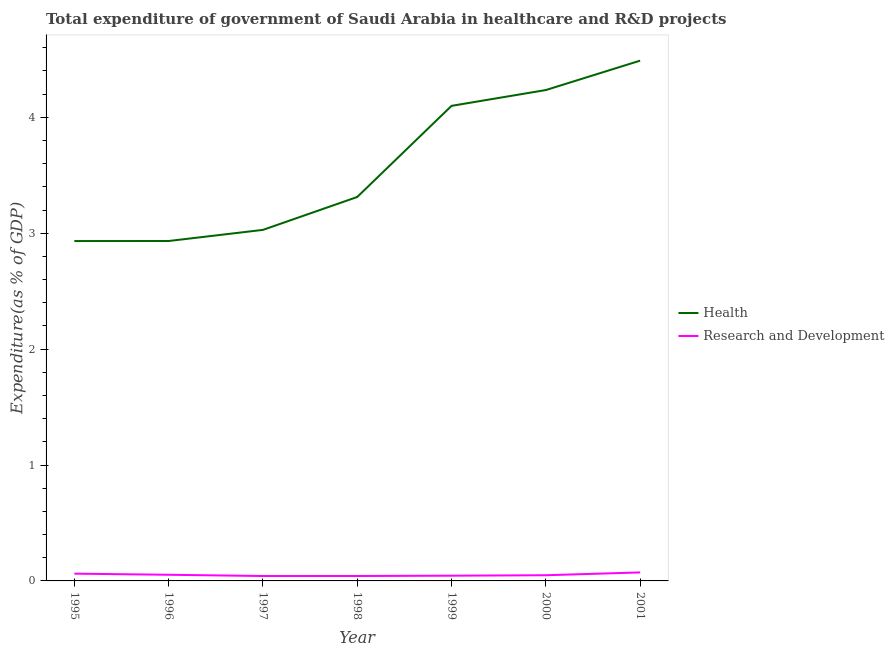Does the line corresponding to expenditure in r&d intersect with the line corresponding to expenditure in healthcare?
Offer a terse response. No. What is the expenditure in r&d in 2001?
Your response must be concise. 0.07. Across all years, what is the maximum expenditure in r&d?
Offer a very short reply. 0.07. Across all years, what is the minimum expenditure in r&d?
Provide a succinct answer. 0.04. In which year was the expenditure in r&d maximum?
Your response must be concise. 2001. What is the total expenditure in healthcare in the graph?
Your answer should be very brief. 25.03. What is the difference between the expenditure in healthcare in 1995 and that in 1996?
Offer a terse response. -0. What is the difference between the expenditure in r&d in 2001 and the expenditure in healthcare in 1999?
Your response must be concise. -4.03. What is the average expenditure in r&d per year?
Make the answer very short. 0.05. In the year 1999, what is the difference between the expenditure in healthcare and expenditure in r&d?
Your answer should be very brief. 4.05. In how many years, is the expenditure in healthcare greater than 2 %?
Make the answer very short. 7. What is the ratio of the expenditure in r&d in 1995 to that in 1999?
Provide a succinct answer. 1.39. What is the difference between the highest and the second highest expenditure in healthcare?
Provide a short and direct response. 0.25. What is the difference between the highest and the lowest expenditure in r&d?
Ensure brevity in your answer.  0.03. In how many years, is the expenditure in r&d greater than the average expenditure in r&d taken over all years?
Provide a short and direct response. 3. Does the expenditure in r&d monotonically increase over the years?
Offer a terse response. No. How many years are there in the graph?
Offer a terse response. 7. Where does the legend appear in the graph?
Your response must be concise. Center right. What is the title of the graph?
Your answer should be very brief. Total expenditure of government of Saudi Arabia in healthcare and R&D projects. Does "Arms imports" appear as one of the legend labels in the graph?
Your answer should be compact. No. What is the label or title of the Y-axis?
Give a very brief answer. Expenditure(as % of GDP). What is the Expenditure(as % of GDP) in Health in 1995?
Your answer should be compact. 2.93. What is the Expenditure(as % of GDP) in Research and Development in 1995?
Offer a terse response. 0.06. What is the Expenditure(as % of GDP) of Health in 1996?
Keep it short and to the point. 2.93. What is the Expenditure(as % of GDP) of Research and Development in 1996?
Offer a very short reply. 0.05. What is the Expenditure(as % of GDP) of Health in 1997?
Your response must be concise. 3.03. What is the Expenditure(as % of GDP) in Research and Development in 1997?
Your answer should be compact. 0.04. What is the Expenditure(as % of GDP) of Health in 1998?
Offer a very short reply. 3.31. What is the Expenditure(as % of GDP) in Research and Development in 1998?
Offer a terse response. 0.04. What is the Expenditure(as % of GDP) in Health in 1999?
Ensure brevity in your answer.  4.1. What is the Expenditure(as % of GDP) of Research and Development in 1999?
Your response must be concise. 0.05. What is the Expenditure(as % of GDP) in Health in 2000?
Give a very brief answer. 4.24. What is the Expenditure(as % of GDP) of Research and Development in 2000?
Offer a very short reply. 0.05. What is the Expenditure(as % of GDP) of Health in 2001?
Keep it short and to the point. 4.49. What is the Expenditure(as % of GDP) in Research and Development in 2001?
Offer a terse response. 0.07. Across all years, what is the maximum Expenditure(as % of GDP) in Health?
Offer a very short reply. 4.49. Across all years, what is the maximum Expenditure(as % of GDP) in Research and Development?
Keep it short and to the point. 0.07. Across all years, what is the minimum Expenditure(as % of GDP) in Health?
Your response must be concise. 2.93. Across all years, what is the minimum Expenditure(as % of GDP) of Research and Development?
Offer a very short reply. 0.04. What is the total Expenditure(as % of GDP) of Health in the graph?
Provide a short and direct response. 25.03. What is the total Expenditure(as % of GDP) of Research and Development in the graph?
Offer a terse response. 0.37. What is the difference between the Expenditure(as % of GDP) of Health in 1995 and that in 1996?
Your answer should be very brief. -0. What is the difference between the Expenditure(as % of GDP) of Research and Development in 1995 and that in 1996?
Provide a short and direct response. 0.01. What is the difference between the Expenditure(as % of GDP) in Health in 1995 and that in 1997?
Your answer should be compact. -0.1. What is the difference between the Expenditure(as % of GDP) of Research and Development in 1995 and that in 1997?
Provide a short and direct response. 0.02. What is the difference between the Expenditure(as % of GDP) of Health in 1995 and that in 1998?
Make the answer very short. -0.38. What is the difference between the Expenditure(as % of GDP) of Research and Development in 1995 and that in 1998?
Your response must be concise. 0.02. What is the difference between the Expenditure(as % of GDP) of Health in 1995 and that in 1999?
Ensure brevity in your answer.  -1.17. What is the difference between the Expenditure(as % of GDP) in Research and Development in 1995 and that in 1999?
Make the answer very short. 0.02. What is the difference between the Expenditure(as % of GDP) of Health in 1995 and that in 2000?
Offer a very short reply. -1.3. What is the difference between the Expenditure(as % of GDP) in Research and Development in 1995 and that in 2000?
Keep it short and to the point. 0.01. What is the difference between the Expenditure(as % of GDP) in Health in 1995 and that in 2001?
Keep it short and to the point. -1.56. What is the difference between the Expenditure(as % of GDP) of Research and Development in 1995 and that in 2001?
Offer a very short reply. -0.01. What is the difference between the Expenditure(as % of GDP) in Health in 1996 and that in 1997?
Offer a terse response. -0.1. What is the difference between the Expenditure(as % of GDP) of Research and Development in 1996 and that in 1997?
Provide a short and direct response. 0.01. What is the difference between the Expenditure(as % of GDP) of Health in 1996 and that in 1998?
Provide a short and direct response. -0.38. What is the difference between the Expenditure(as % of GDP) in Research and Development in 1996 and that in 1998?
Your answer should be very brief. 0.01. What is the difference between the Expenditure(as % of GDP) in Health in 1996 and that in 1999?
Offer a terse response. -1.17. What is the difference between the Expenditure(as % of GDP) in Research and Development in 1996 and that in 1999?
Provide a short and direct response. 0.01. What is the difference between the Expenditure(as % of GDP) in Health in 1996 and that in 2000?
Make the answer very short. -1.3. What is the difference between the Expenditure(as % of GDP) in Research and Development in 1996 and that in 2000?
Give a very brief answer. 0. What is the difference between the Expenditure(as % of GDP) in Health in 1996 and that in 2001?
Make the answer very short. -1.56. What is the difference between the Expenditure(as % of GDP) in Research and Development in 1996 and that in 2001?
Offer a very short reply. -0.02. What is the difference between the Expenditure(as % of GDP) of Health in 1997 and that in 1998?
Give a very brief answer. -0.28. What is the difference between the Expenditure(as % of GDP) in Research and Development in 1997 and that in 1998?
Your response must be concise. -0. What is the difference between the Expenditure(as % of GDP) in Health in 1997 and that in 1999?
Provide a short and direct response. -1.07. What is the difference between the Expenditure(as % of GDP) in Research and Development in 1997 and that in 1999?
Your response must be concise. -0. What is the difference between the Expenditure(as % of GDP) of Health in 1997 and that in 2000?
Give a very brief answer. -1.21. What is the difference between the Expenditure(as % of GDP) of Research and Development in 1997 and that in 2000?
Your answer should be very brief. -0.01. What is the difference between the Expenditure(as % of GDP) of Health in 1997 and that in 2001?
Your response must be concise. -1.46. What is the difference between the Expenditure(as % of GDP) of Research and Development in 1997 and that in 2001?
Ensure brevity in your answer.  -0.03. What is the difference between the Expenditure(as % of GDP) of Health in 1998 and that in 1999?
Your answer should be compact. -0.79. What is the difference between the Expenditure(as % of GDP) of Research and Development in 1998 and that in 1999?
Your answer should be compact. -0. What is the difference between the Expenditure(as % of GDP) of Health in 1998 and that in 2000?
Your answer should be very brief. -0.92. What is the difference between the Expenditure(as % of GDP) in Research and Development in 1998 and that in 2000?
Offer a very short reply. -0.01. What is the difference between the Expenditure(as % of GDP) in Health in 1998 and that in 2001?
Offer a very short reply. -1.18. What is the difference between the Expenditure(as % of GDP) of Research and Development in 1998 and that in 2001?
Provide a succinct answer. -0.03. What is the difference between the Expenditure(as % of GDP) of Health in 1999 and that in 2000?
Provide a succinct answer. -0.14. What is the difference between the Expenditure(as % of GDP) in Research and Development in 1999 and that in 2000?
Offer a very short reply. -0. What is the difference between the Expenditure(as % of GDP) in Health in 1999 and that in 2001?
Your response must be concise. -0.39. What is the difference between the Expenditure(as % of GDP) in Research and Development in 1999 and that in 2001?
Provide a succinct answer. -0.03. What is the difference between the Expenditure(as % of GDP) of Health in 2000 and that in 2001?
Provide a succinct answer. -0.25. What is the difference between the Expenditure(as % of GDP) of Research and Development in 2000 and that in 2001?
Provide a succinct answer. -0.02. What is the difference between the Expenditure(as % of GDP) of Health in 1995 and the Expenditure(as % of GDP) of Research and Development in 1996?
Your answer should be compact. 2.88. What is the difference between the Expenditure(as % of GDP) in Health in 1995 and the Expenditure(as % of GDP) in Research and Development in 1997?
Offer a terse response. 2.89. What is the difference between the Expenditure(as % of GDP) of Health in 1995 and the Expenditure(as % of GDP) of Research and Development in 1998?
Make the answer very short. 2.89. What is the difference between the Expenditure(as % of GDP) of Health in 1995 and the Expenditure(as % of GDP) of Research and Development in 1999?
Your answer should be compact. 2.89. What is the difference between the Expenditure(as % of GDP) in Health in 1995 and the Expenditure(as % of GDP) in Research and Development in 2000?
Your response must be concise. 2.88. What is the difference between the Expenditure(as % of GDP) of Health in 1995 and the Expenditure(as % of GDP) of Research and Development in 2001?
Offer a very short reply. 2.86. What is the difference between the Expenditure(as % of GDP) of Health in 1996 and the Expenditure(as % of GDP) of Research and Development in 1997?
Give a very brief answer. 2.89. What is the difference between the Expenditure(as % of GDP) of Health in 1996 and the Expenditure(as % of GDP) of Research and Development in 1998?
Give a very brief answer. 2.89. What is the difference between the Expenditure(as % of GDP) of Health in 1996 and the Expenditure(as % of GDP) of Research and Development in 1999?
Offer a very short reply. 2.89. What is the difference between the Expenditure(as % of GDP) in Health in 1996 and the Expenditure(as % of GDP) in Research and Development in 2000?
Offer a very short reply. 2.88. What is the difference between the Expenditure(as % of GDP) of Health in 1996 and the Expenditure(as % of GDP) of Research and Development in 2001?
Give a very brief answer. 2.86. What is the difference between the Expenditure(as % of GDP) in Health in 1997 and the Expenditure(as % of GDP) in Research and Development in 1998?
Keep it short and to the point. 2.99. What is the difference between the Expenditure(as % of GDP) of Health in 1997 and the Expenditure(as % of GDP) of Research and Development in 1999?
Offer a very short reply. 2.98. What is the difference between the Expenditure(as % of GDP) in Health in 1997 and the Expenditure(as % of GDP) in Research and Development in 2000?
Keep it short and to the point. 2.98. What is the difference between the Expenditure(as % of GDP) in Health in 1997 and the Expenditure(as % of GDP) in Research and Development in 2001?
Provide a succinct answer. 2.96. What is the difference between the Expenditure(as % of GDP) in Health in 1998 and the Expenditure(as % of GDP) in Research and Development in 1999?
Your answer should be very brief. 3.27. What is the difference between the Expenditure(as % of GDP) of Health in 1998 and the Expenditure(as % of GDP) of Research and Development in 2000?
Your response must be concise. 3.26. What is the difference between the Expenditure(as % of GDP) in Health in 1998 and the Expenditure(as % of GDP) in Research and Development in 2001?
Give a very brief answer. 3.24. What is the difference between the Expenditure(as % of GDP) of Health in 1999 and the Expenditure(as % of GDP) of Research and Development in 2000?
Your answer should be compact. 4.05. What is the difference between the Expenditure(as % of GDP) of Health in 1999 and the Expenditure(as % of GDP) of Research and Development in 2001?
Give a very brief answer. 4.03. What is the difference between the Expenditure(as % of GDP) of Health in 2000 and the Expenditure(as % of GDP) of Research and Development in 2001?
Your answer should be very brief. 4.16. What is the average Expenditure(as % of GDP) of Health per year?
Provide a short and direct response. 3.58. What is the average Expenditure(as % of GDP) of Research and Development per year?
Your answer should be very brief. 0.05. In the year 1995, what is the difference between the Expenditure(as % of GDP) in Health and Expenditure(as % of GDP) in Research and Development?
Keep it short and to the point. 2.87. In the year 1996, what is the difference between the Expenditure(as % of GDP) of Health and Expenditure(as % of GDP) of Research and Development?
Keep it short and to the point. 2.88. In the year 1997, what is the difference between the Expenditure(as % of GDP) of Health and Expenditure(as % of GDP) of Research and Development?
Your answer should be compact. 2.99. In the year 1998, what is the difference between the Expenditure(as % of GDP) in Health and Expenditure(as % of GDP) in Research and Development?
Offer a terse response. 3.27. In the year 1999, what is the difference between the Expenditure(as % of GDP) of Health and Expenditure(as % of GDP) of Research and Development?
Offer a terse response. 4.05. In the year 2000, what is the difference between the Expenditure(as % of GDP) in Health and Expenditure(as % of GDP) in Research and Development?
Offer a very short reply. 4.19. In the year 2001, what is the difference between the Expenditure(as % of GDP) in Health and Expenditure(as % of GDP) in Research and Development?
Offer a terse response. 4.42. What is the ratio of the Expenditure(as % of GDP) in Research and Development in 1995 to that in 1996?
Keep it short and to the point. 1.18. What is the ratio of the Expenditure(as % of GDP) in Health in 1995 to that in 1997?
Offer a very short reply. 0.97. What is the ratio of the Expenditure(as % of GDP) in Research and Development in 1995 to that in 1997?
Provide a short and direct response. 1.48. What is the ratio of the Expenditure(as % of GDP) in Health in 1995 to that in 1998?
Make the answer very short. 0.89. What is the ratio of the Expenditure(as % of GDP) in Research and Development in 1995 to that in 1998?
Your response must be concise. 1.48. What is the ratio of the Expenditure(as % of GDP) in Health in 1995 to that in 1999?
Offer a terse response. 0.72. What is the ratio of the Expenditure(as % of GDP) in Research and Development in 1995 to that in 1999?
Ensure brevity in your answer.  1.39. What is the ratio of the Expenditure(as % of GDP) in Health in 1995 to that in 2000?
Your answer should be compact. 0.69. What is the ratio of the Expenditure(as % of GDP) of Research and Development in 1995 to that in 2000?
Your response must be concise. 1.28. What is the ratio of the Expenditure(as % of GDP) of Health in 1995 to that in 2001?
Ensure brevity in your answer.  0.65. What is the ratio of the Expenditure(as % of GDP) of Research and Development in 1995 to that in 2001?
Your answer should be compact. 0.85. What is the ratio of the Expenditure(as % of GDP) in Health in 1996 to that in 1997?
Give a very brief answer. 0.97. What is the ratio of the Expenditure(as % of GDP) of Research and Development in 1996 to that in 1997?
Keep it short and to the point. 1.26. What is the ratio of the Expenditure(as % of GDP) of Health in 1996 to that in 1998?
Your answer should be very brief. 0.89. What is the ratio of the Expenditure(as % of GDP) in Research and Development in 1996 to that in 1998?
Your answer should be very brief. 1.25. What is the ratio of the Expenditure(as % of GDP) in Health in 1996 to that in 1999?
Keep it short and to the point. 0.72. What is the ratio of the Expenditure(as % of GDP) in Research and Development in 1996 to that in 1999?
Your answer should be compact. 1.18. What is the ratio of the Expenditure(as % of GDP) of Health in 1996 to that in 2000?
Offer a terse response. 0.69. What is the ratio of the Expenditure(as % of GDP) in Research and Development in 1996 to that in 2000?
Provide a succinct answer. 1.08. What is the ratio of the Expenditure(as % of GDP) of Health in 1996 to that in 2001?
Keep it short and to the point. 0.65. What is the ratio of the Expenditure(as % of GDP) in Research and Development in 1996 to that in 2001?
Your answer should be compact. 0.72. What is the ratio of the Expenditure(as % of GDP) in Health in 1997 to that in 1998?
Provide a succinct answer. 0.91. What is the ratio of the Expenditure(as % of GDP) in Research and Development in 1997 to that in 1998?
Offer a very short reply. 1. What is the ratio of the Expenditure(as % of GDP) in Health in 1997 to that in 1999?
Provide a succinct answer. 0.74. What is the ratio of the Expenditure(as % of GDP) of Research and Development in 1997 to that in 1999?
Your answer should be compact. 0.94. What is the ratio of the Expenditure(as % of GDP) of Health in 1997 to that in 2000?
Provide a short and direct response. 0.72. What is the ratio of the Expenditure(as % of GDP) of Research and Development in 1997 to that in 2000?
Ensure brevity in your answer.  0.86. What is the ratio of the Expenditure(as % of GDP) of Health in 1997 to that in 2001?
Provide a short and direct response. 0.67. What is the ratio of the Expenditure(as % of GDP) of Research and Development in 1997 to that in 2001?
Offer a very short reply. 0.58. What is the ratio of the Expenditure(as % of GDP) of Health in 1998 to that in 1999?
Make the answer very short. 0.81. What is the ratio of the Expenditure(as % of GDP) of Research and Development in 1998 to that in 1999?
Ensure brevity in your answer.  0.94. What is the ratio of the Expenditure(as % of GDP) of Health in 1998 to that in 2000?
Your response must be concise. 0.78. What is the ratio of the Expenditure(as % of GDP) in Research and Development in 1998 to that in 2000?
Offer a very short reply. 0.87. What is the ratio of the Expenditure(as % of GDP) of Health in 1998 to that in 2001?
Offer a very short reply. 0.74. What is the ratio of the Expenditure(as % of GDP) of Research and Development in 1998 to that in 2001?
Give a very brief answer. 0.58. What is the ratio of the Expenditure(as % of GDP) of Health in 1999 to that in 2000?
Provide a succinct answer. 0.97. What is the ratio of the Expenditure(as % of GDP) in Research and Development in 1999 to that in 2000?
Your response must be concise. 0.92. What is the ratio of the Expenditure(as % of GDP) in Health in 1999 to that in 2001?
Make the answer very short. 0.91. What is the ratio of the Expenditure(as % of GDP) of Research and Development in 1999 to that in 2001?
Provide a short and direct response. 0.62. What is the ratio of the Expenditure(as % of GDP) in Health in 2000 to that in 2001?
Your answer should be compact. 0.94. What is the ratio of the Expenditure(as % of GDP) of Research and Development in 2000 to that in 2001?
Provide a succinct answer. 0.67. What is the difference between the highest and the second highest Expenditure(as % of GDP) of Health?
Your response must be concise. 0.25. What is the difference between the highest and the second highest Expenditure(as % of GDP) of Research and Development?
Give a very brief answer. 0.01. What is the difference between the highest and the lowest Expenditure(as % of GDP) in Health?
Provide a succinct answer. 1.56. What is the difference between the highest and the lowest Expenditure(as % of GDP) in Research and Development?
Your answer should be very brief. 0.03. 